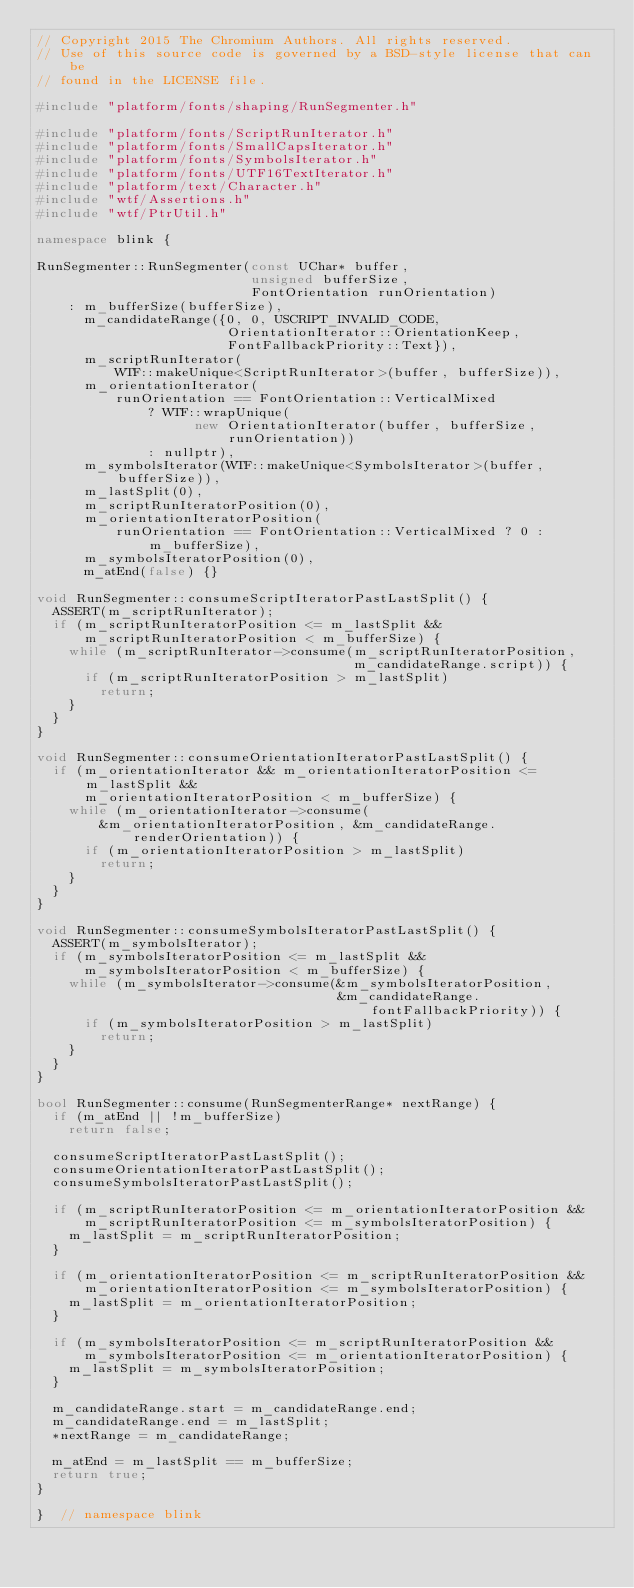<code> <loc_0><loc_0><loc_500><loc_500><_C++_>// Copyright 2015 The Chromium Authors. All rights reserved.
// Use of this source code is governed by a BSD-style license that can be
// found in the LICENSE file.

#include "platform/fonts/shaping/RunSegmenter.h"

#include "platform/fonts/ScriptRunIterator.h"
#include "platform/fonts/SmallCapsIterator.h"
#include "platform/fonts/SymbolsIterator.h"
#include "platform/fonts/UTF16TextIterator.h"
#include "platform/text/Character.h"
#include "wtf/Assertions.h"
#include "wtf/PtrUtil.h"

namespace blink {

RunSegmenter::RunSegmenter(const UChar* buffer,
                           unsigned bufferSize,
                           FontOrientation runOrientation)
    : m_bufferSize(bufferSize),
      m_candidateRange({0, 0, USCRIPT_INVALID_CODE,
                        OrientationIterator::OrientationKeep,
                        FontFallbackPriority::Text}),
      m_scriptRunIterator(
          WTF::makeUnique<ScriptRunIterator>(buffer, bufferSize)),
      m_orientationIterator(
          runOrientation == FontOrientation::VerticalMixed
              ? WTF::wrapUnique(
                    new OrientationIterator(buffer, bufferSize, runOrientation))
              : nullptr),
      m_symbolsIterator(WTF::makeUnique<SymbolsIterator>(buffer, bufferSize)),
      m_lastSplit(0),
      m_scriptRunIteratorPosition(0),
      m_orientationIteratorPosition(
          runOrientation == FontOrientation::VerticalMixed ? 0 : m_bufferSize),
      m_symbolsIteratorPosition(0),
      m_atEnd(false) {}

void RunSegmenter::consumeScriptIteratorPastLastSplit() {
  ASSERT(m_scriptRunIterator);
  if (m_scriptRunIteratorPosition <= m_lastSplit &&
      m_scriptRunIteratorPosition < m_bufferSize) {
    while (m_scriptRunIterator->consume(m_scriptRunIteratorPosition,
                                        m_candidateRange.script)) {
      if (m_scriptRunIteratorPosition > m_lastSplit)
        return;
    }
  }
}

void RunSegmenter::consumeOrientationIteratorPastLastSplit() {
  if (m_orientationIterator && m_orientationIteratorPosition <= m_lastSplit &&
      m_orientationIteratorPosition < m_bufferSize) {
    while (m_orientationIterator->consume(
        &m_orientationIteratorPosition, &m_candidateRange.renderOrientation)) {
      if (m_orientationIteratorPosition > m_lastSplit)
        return;
    }
  }
}

void RunSegmenter::consumeSymbolsIteratorPastLastSplit() {
  ASSERT(m_symbolsIterator);
  if (m_symbolsIteratorPosition <= m_lastSplit &&
      m_symbolsIteratorPosition < m_bufferSize) {
    while (m_symbolsIterator->consume(&m_symbolsIteratorPosition,
                                      &m_candidateRange.fontFallbackPriority)) {
      if (m_symbolsIteratorPosition > m_lastSplit)
        return;
    }
  }
}

bool RunSegmenter::consume(RunSegmenterRange* nextRange) {
  if (m_atEnd || !m_bufferSize)
    return false;

  consumeScriptIteratorPastLastSplit();
  consumeOrientationIteratorPastLastSplit();
  consumeSymbolsIteratorPastLastSplit();

  if (m_scriptRunIteratorPosition <= m_orientationIteratorPosition &&
      m_scriptRunIteratorPosition <= m_symbolsIteratorPosition) {
    m_lastSplit = m_scriptRunIteratorPosition;
  }

  if (m_orientationIteratorPosition <= m_scriptRunIteratorPosition &&
      m_orientationIteratorPosition <= m_symbolsIteratorPosition) {
    m_lastSplit = m_orientationIteratorPosition;
  }

  if (m_symbolsIteratorPosition <= m_scriptRunIteratorPosition &&
      m_symbolsIteratorPosition <= m_orientationIteratorPosition) {
    m_lastSplit = m_symbolsIteratorPosition;
  }

  m_candidateRange.start = m_candidateRange.end;
  m_candidateRange.end = m_lastSplit;
  *nextRange = m_candidateRange;

  m_atEnd = m_lastSplit == m_bufferSize;
  return true;
}

}  // namespace blink
</code> 